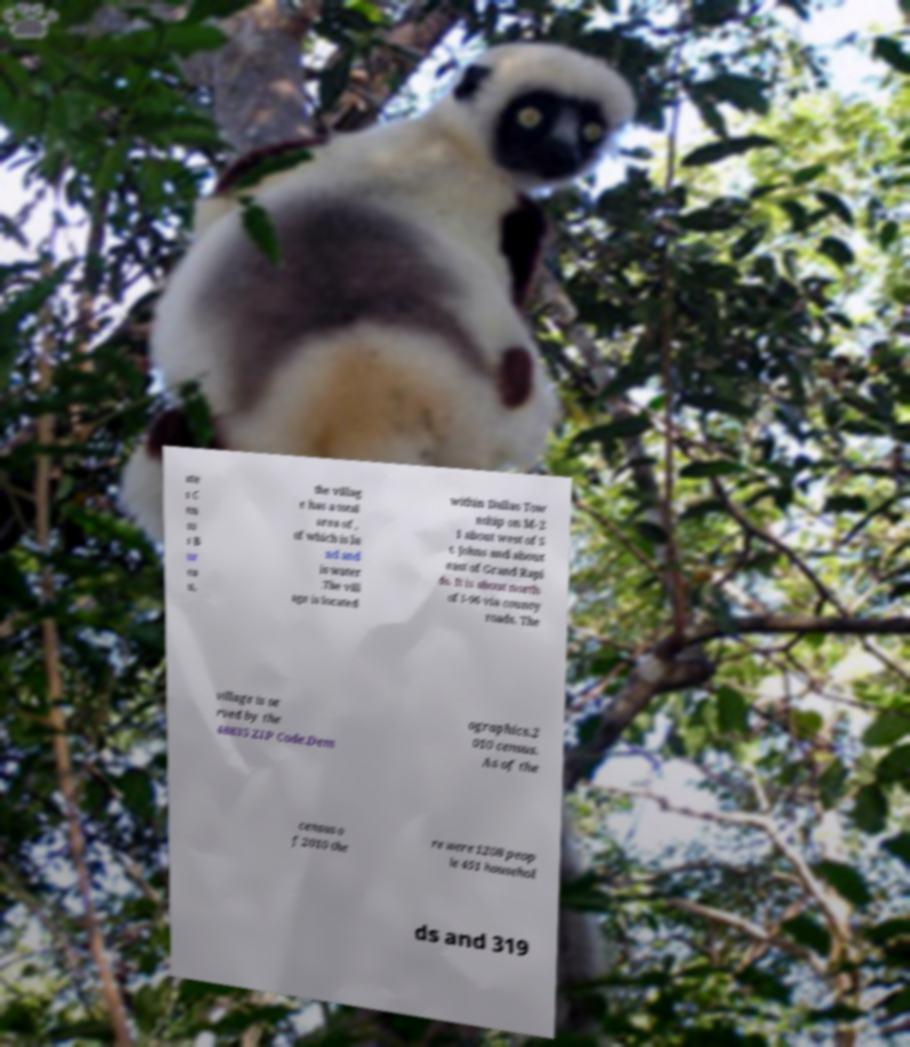What messages or text are displayed in this image? I need them in a readable, typed format. ate s C en su s B ur ea u, the villag e has a total area of , of which is la nd and is water .The vill age is located within Dallas Tow nship on M-2 1 about west of S t. Johns and about east of Grand Rapi ds. It is about north of I-96 via county roads. The village is se rved by the 48835 ZIP Code.Dem ographics.2 010 census. As of the census o f 2010 the re were 1208 peop le 451 househol ds and 319 